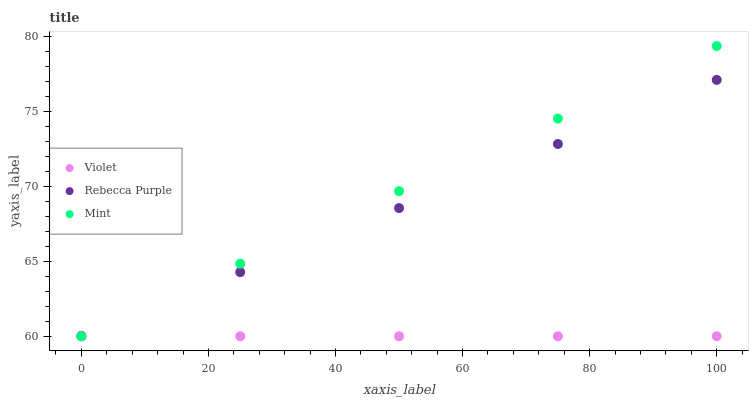Does Violet have the minimum area under the curve?
Answer yes or no. Yes. Does Mint have the maximum area under the curve?
Answer yes or no. Yes. Does Rebecca Purple have the minimum area under the curve?
Answer yes or no. No. Does Rebecca Purple have the maximum area under the curve?
Answer yes or no. No. Is Mint the smoothest?
Answer yes or no. Yes. Is Violet the roughest?
Answer yes or no. Yes. Is Rebecca Purple the smoothest?
Answer yes or no. No. Is Rebecca Purple the roughest?
Answer yes or no. No. Does Mint have the lowest value?
Answer yes or no. Yes. Does Mint have the highest value?
Answer yes or no. Yes. Does Rebecca Purple have the highest value?
Answer yes or no. No. Does Mint intersect Rebecca Purple?
Answer yes or no. Yes. Is Mint less than Rebecca Purple?
Answer yes or no. No. Is Mint greater than Rebecca Purple?
Answer yes or no. No. 